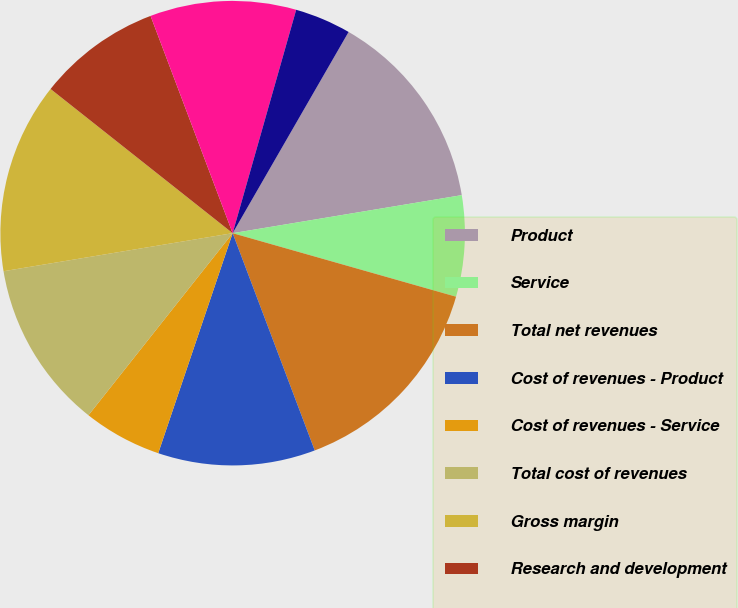<chart> <loc_0><loc_0><loc_500><loc_500><pie_chart><fcel>Product<fcel>Service<fcel>Total net revenues<fcel>Cost of revenues - Product<fcel>Cost of revenues - Service<fcel>Total cost of revenues<fcel>Gross margin<fcel>Research and development<fcel>Sales and marketing<fcel>General and administrative<nl><fcel>14.06%<fcel>7.03%<fcel>14.84%<fcel>10.94%<fcel>5.47%<fcel>11.72%<fcel>13.28%<fcel>8.59%<fcel>10.16%<fcel>3.91%<nl></chart> 